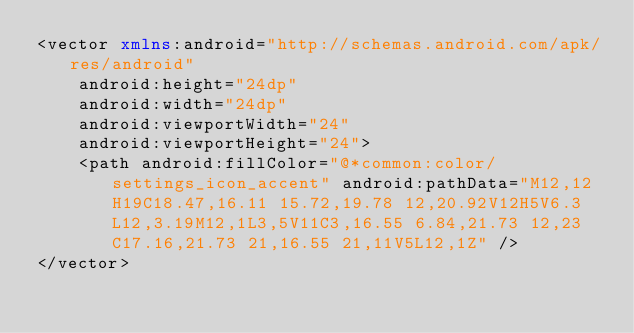Convert code to text. <code><loc_0><loc_0><loc_500><loc_500><_XML_><vector xmlns:android="http://schemas.android.com/apk/res/android"
    android:height="24dp"
    android:width="24dp"
    android:viewportWidth="24"
    android:viewportHeight="24">
    <path android:fillColor="@*common:color/settings_icon_accent" android:pathData="M12,12H19C18.47,16.11 15.72,19.78 12,20.92V12H5V6.3L12,3.19M12,1L3,5V11C3,16.55 6.84,21.73 12,23C17.16,21.73 21,16.55 21,11V5L12,1Z" />
</vector></code> 